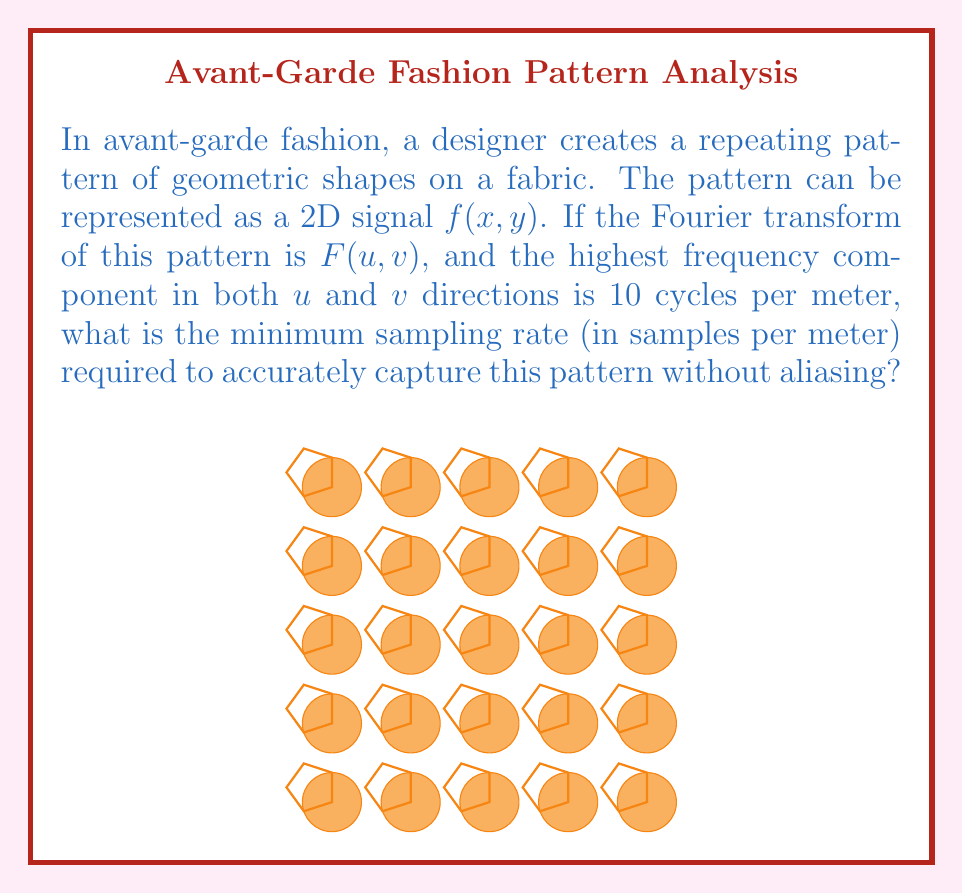Solve this math problem. To solve this problem, we need to apply the Nyquist-Shannon sampling theorem to 2D signals. Here's a step-by-step explanation:

1) The Nyquist-Shannon sampling theorem states that to accurately reconstruct a signal, the sampling rate must be at least twice the highest frequency component in the signal.

2) In this case, we have a 2D signal (the fabric pattern) with a Fourier transform $F(u,v)$.

3) The highest frequency component in both $u$ and $v$ directions is given as 10 cycles per meter.

4) To avoid aliasing, we need to sample at least twice this frequency in both directions:

   $$f_s > 2 \cdot f_{max}$$

   where $f_s$ is the sampling rate and $f_{max}$ is the maximum frequency.

5) Substituting the given value:

   $$f_s > 2 \cdot 10 = 20 \text{ samples per meter}$$

6) Since we're asking for the minimum sampling rate, we need to choose the smallest integer value greater than 20.

Therefore, the minimum sampling rate required is 21 samples per meter in both $x$ and $y$ directions.
Answer: 21 samples per meter 